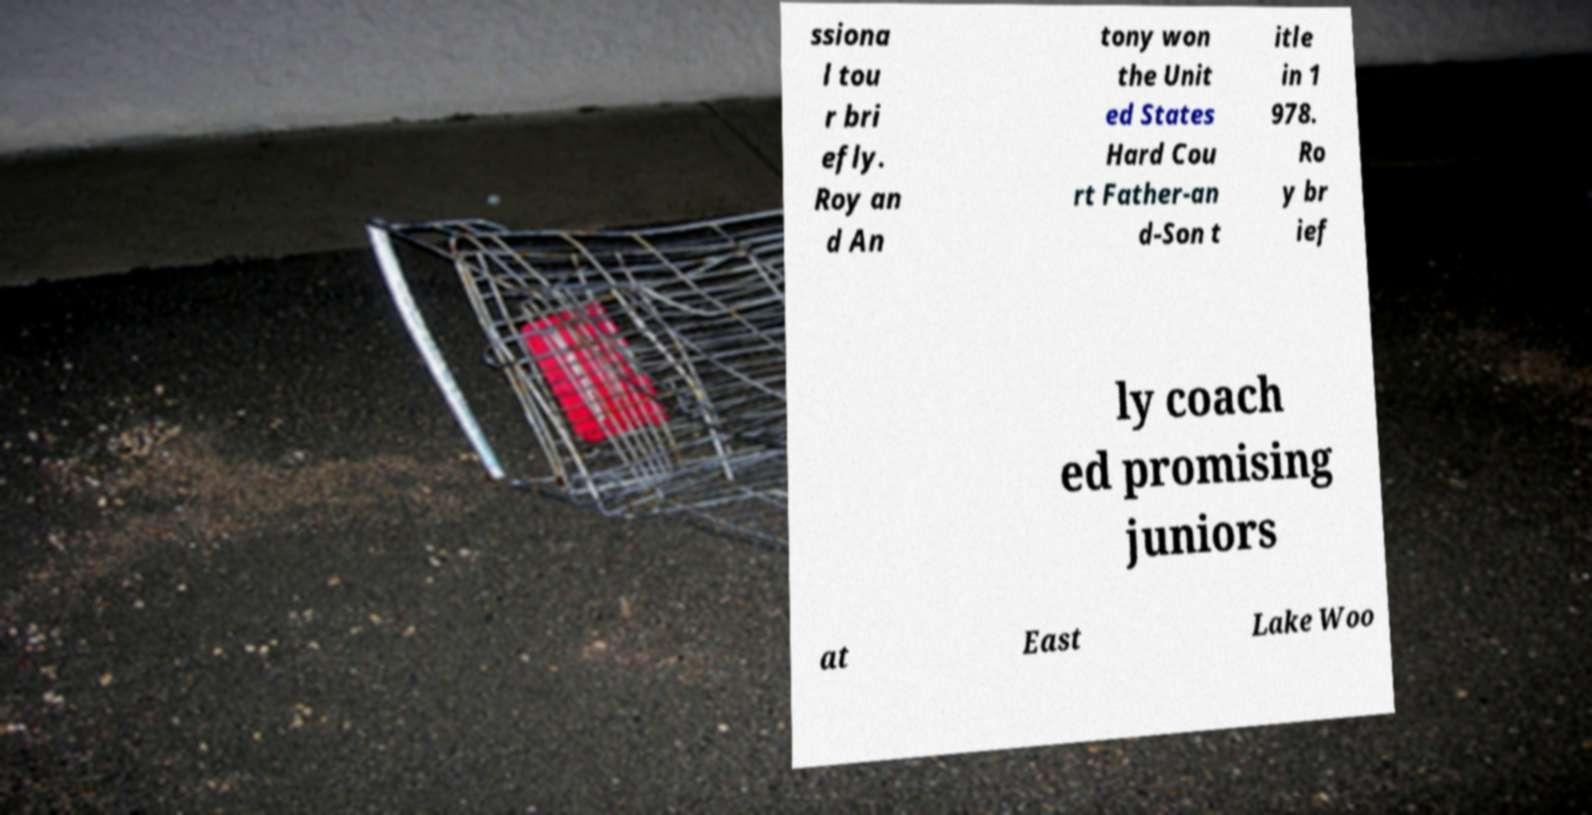There's text embedded in this image that I need extracted. Can you transcribe it verbatim? ssiona l tou r bri efly. Roy an d An tony won the Unit ed States Hard Cou rt Father-an d-Son t itle in 1 978. Ro y br ief ly coach ed promising juniors at East Lake Woo 